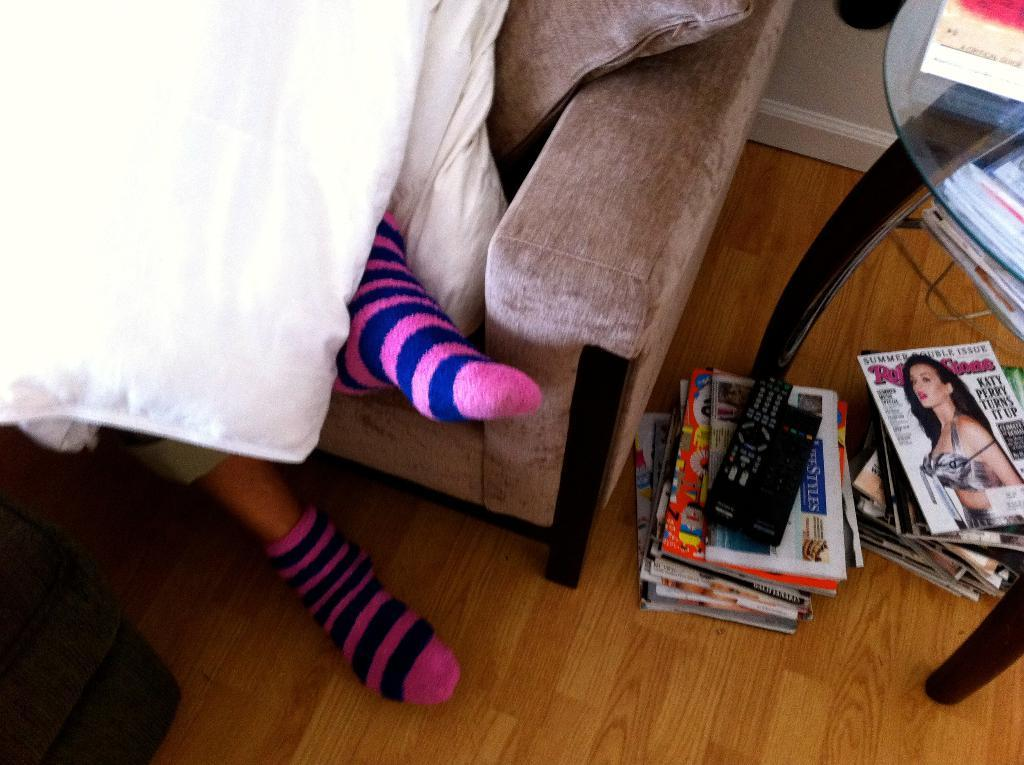What is the person in the image doing? The person is lying on a sofa in the image. What items can be seen near the person? There are magazines and remotes in the image. What is the condition of the floor in the image? There are objects on the floor in the image. What type of furniture is present in the image? There is a glass table in the image. Where might this image have been taken? The image is likely taken in a room. What verse can be seen written on the wall in the image? There is no verse written on the wall in the image; it does not contain any text or writing. 